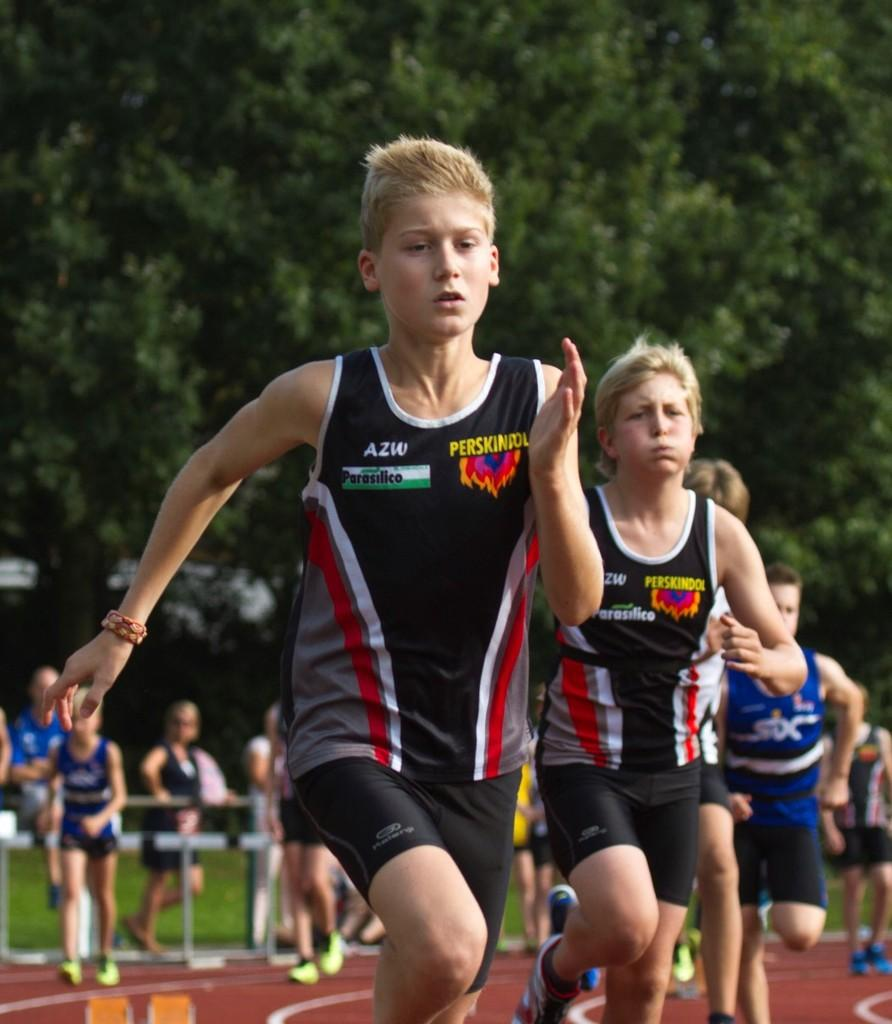<image>
Summarize the visual content of the image. A boy wearing an AZW shirt runs down the track 